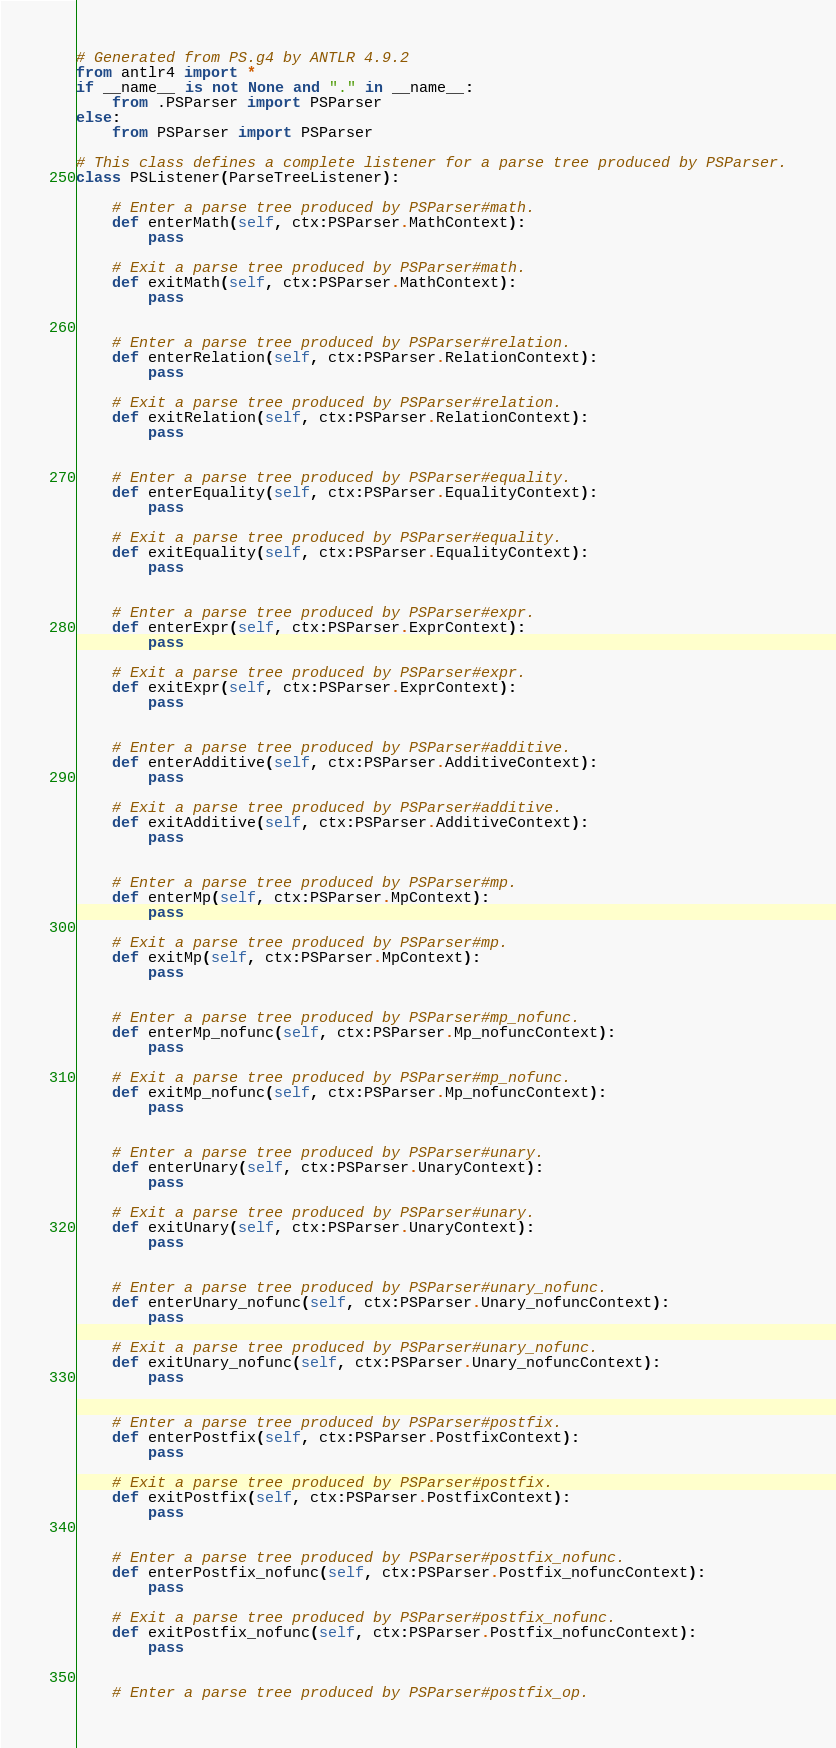Convert code to text. <code><loc_0><loc_0><loc_500><loc_500><_Python_># Generated from PS.g4 by ANTLR 4.9.2
from antlr4 import *
if __name__ is not None and "." in __name__:
    from .PSParser import PSParser
else:
    from PSParser import PSParser

# This class defines a complete listener for a parse tree produced by PSParser.
class PSListener(ParseTreeListener):

    # Enter a parse tree produced by PSParser#math.
    def enterMath(self, ctx:PSParser.MathContext):
        pass

    # Exit a parse tree produced by PSParser#math.
    def exitMath(self, ctx:PSParser.MathContext):
        pass


    # Enter a parse tree produced by PSParser#relation.
    def enterRelation(self, ctx:PSParser.RelationContext):
        pass

    # Exit a parse tree produced by PSParser#relation.
    def exitRelation(self, ctx:PSParser.RelationContext):
        pass


    # Enter a parse tree produced by PSParser#equality.
    def enterEquality(self, ctx:PSParser.EqualityContext):
        pass

    # Exit a parse tree produced by PSParser#equality.
    def exitEquality(self, ctx:PSParser.EqualityContext):
        pass


    # Enter a parse tree produced by PSParser#expr.
    def enterExpr(self, ctx:PSParser.ExprContext):
        pass

    # Exit a parse tree produced by PSParser#expr.
    def exitExpr(self, ctx:PSParser.ExprContext):
        pass


    # Enter a parse tree produced by PSParser#additive.
    def enterAdditive(self, ctx:PSParser.AdditiveContext):
        pass

    # Exit a parse tree produced by PSParser#additive.
    def exitAdditive(self, ctx:PSParser.AdditiveContext):
        pass


    # Enter a parse tree produced by PSParser#mp.
    def enterMp(self, ctx:PSParser.MpContext):
        pass

    # Exit a parse tree produced by PSParser#mp.
    def exitMp(self, ctx:PSParser.MpContext):
        pass


    # Enter a parse tree produced by PSParser#mp_nofunc.
    def enterMp_nofunc(self, ctx:PSParser.Mp_nofuncContext):
        pass

    # Exit a parse tree produced by PSParser#mp_nofunc.
    def exitMp_nofunc(self, ctx:PSParser.Mp_nofuncContext):
        pass


    # Enter a parse tree produced by PSParser#unary.
    def enterUnary(self, ctx:PSParser.UnaryContext):
        pass

    # Exit a parse tree produced by PSParser#unary.
    def exitUnary(self, ctx:PSParser.UnaryContext):
        pass


    # Enter a parse tree produced by PSParser#unary_nofunc.
    def enterUnary_nofunc(self, ctx:PSParser.Unary_nofuncContext):
        pass

    # Exit a parse tree produced by PSParser#unary_nofunc.
    def exitUnary_nofunc(self, ctx:PSParser.Unary_nofuncContext):
        pass


    # Enter a parse tree produced by PSParser#postfix.
    def enterPostfix(self, ctx:PSParser.PostfixContext):
        pass

    # Exit a parse tree produced by PSParser#postfix.
    def exitPostfix(self, ctx:PSParser.PostfixContext):
        pass


    # Enter a parse tree produced by PSParser#postfix_nofunc.
    def enterPostfix_nofunc(self, ctx:PSParser.Postfix_nofuncContext):
        pass

    # Exit a parse tree produced by PSParser#postfix_nofunc.
    def exitPostfix_nofunc(self, ctx:PSParser.Postfix_nofuncContext):
        pass


    # Enter a parse tree produced by PSParser#postfix_op.</code> 